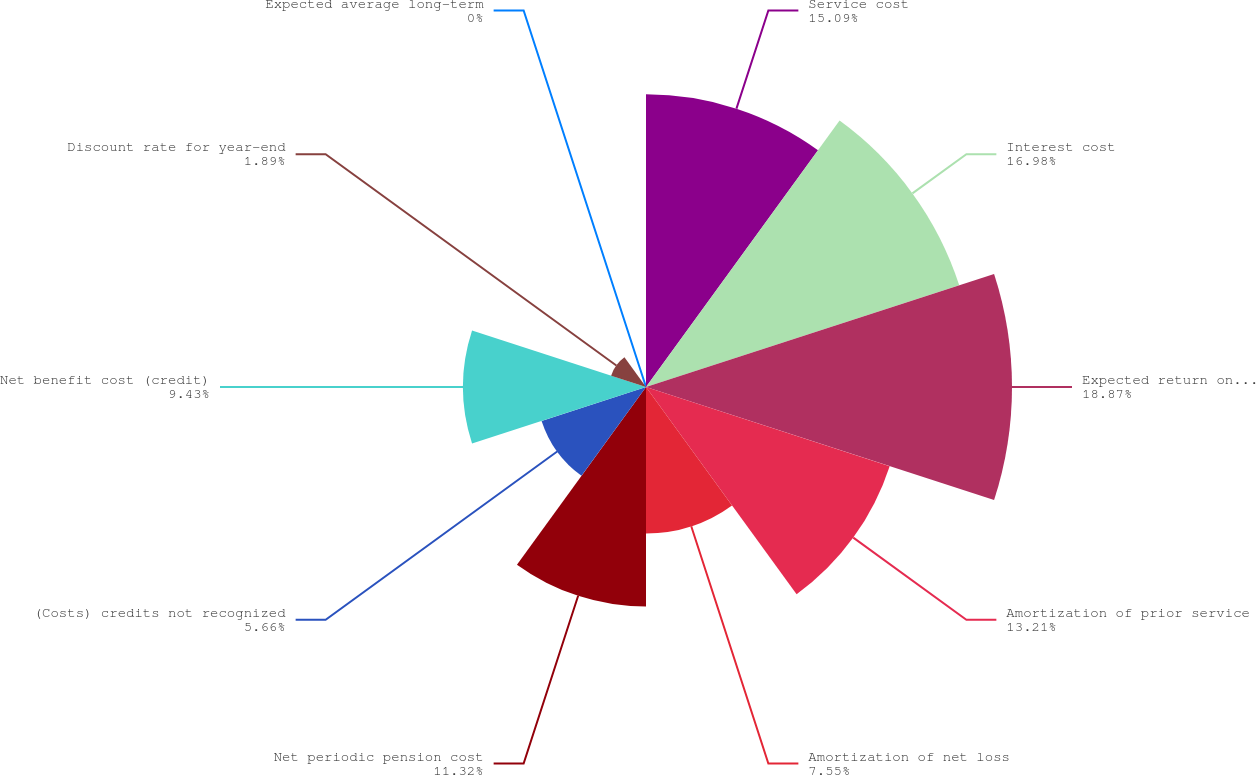Convert chart. <chart><loc_0><loc_0><loc_500><loc_500><pie_chart><fcel>Service cost<fcel>Interest cost<fcel>Expected return on plan assets<fcel>Amortization of prior service<fcel>Amortization of net loss<fcel>Net periodic pension cost<fcel>(Costs) credits not recognized<fcel>Net benefit cost (credit)<fcel>Discount rate for year-end<fcel>Expected average long-term<nl><fcel>15.09%<fcel>16.98%<fcel>18.87%<fcel>13.21%<fcel>7.55%<fcel>11.32%<fcel>5.66%<fcel>9.43%<fcel>1.89%<fcel>0.0%<nl></chart> 